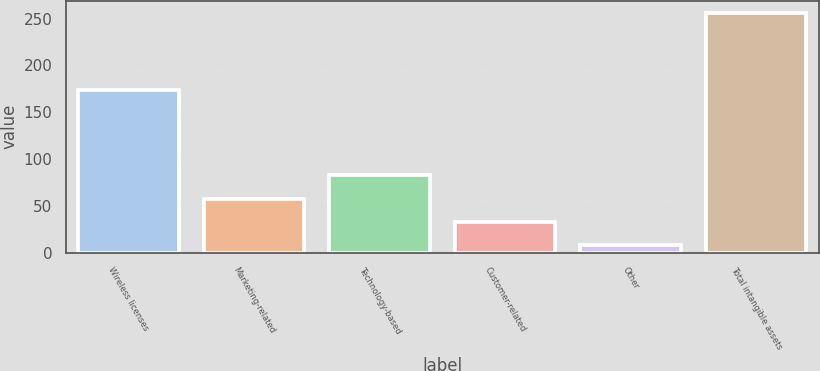Convert chart to OTSL. <chart><loc_0><loc_0><loc_500><loc_500><bar_chart><fcel>Wireless licenses<fcel>Marketing-related<fcel>Technology-based<fcel>Customer-related<fcel>Other<fcel>Total intangible assets<nl><fcel>174<fcel>57.6<fcel>82.4<fcel>32.8<fcel>8<fcel>256<nl></chart> 